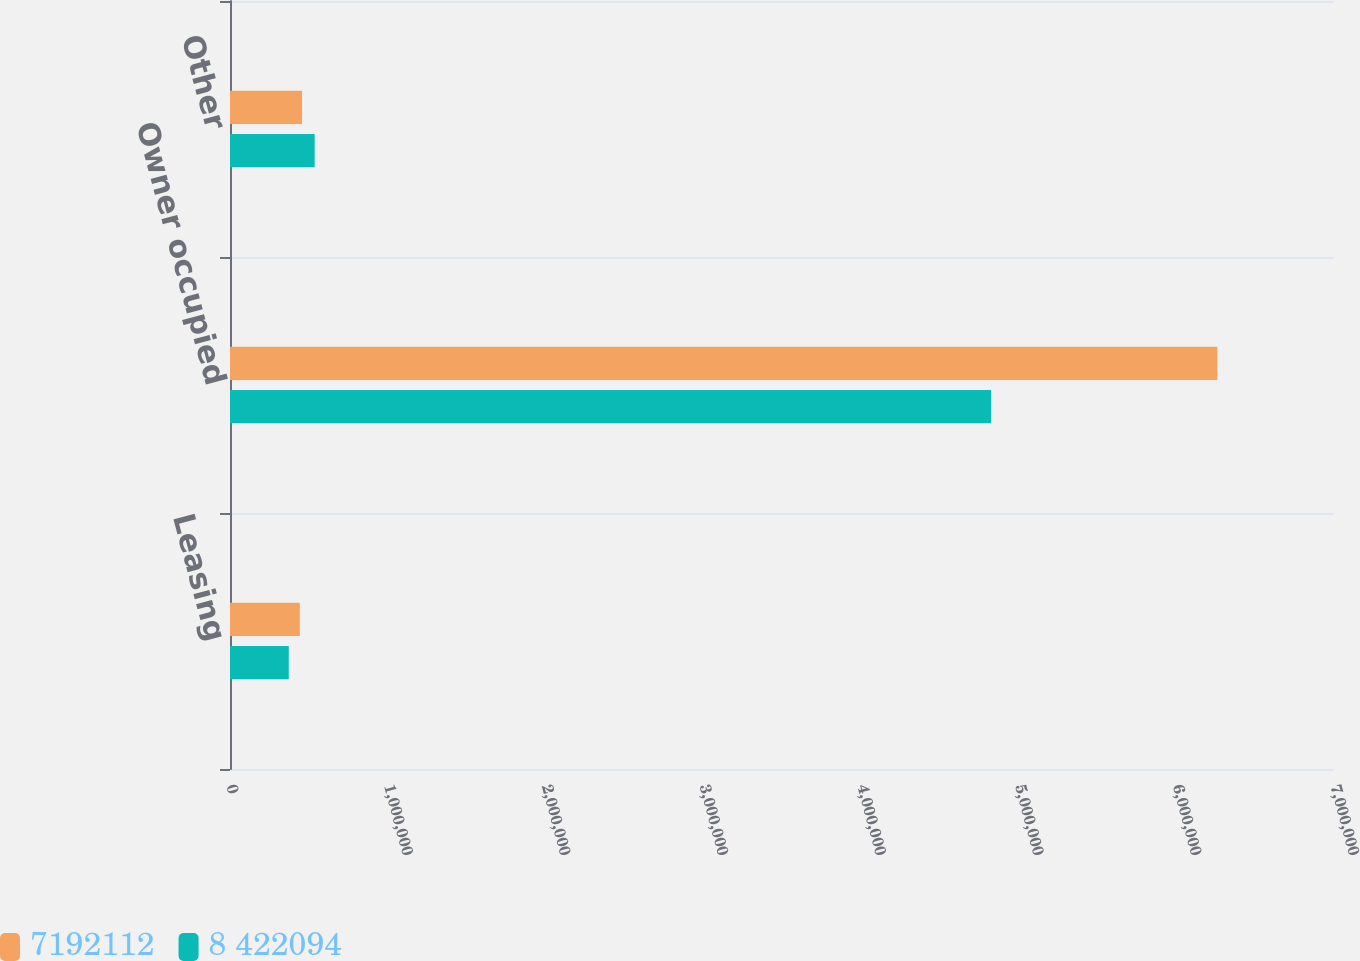Convert chart. <chart><loc_0><loc_0><loc_500><loc_500><stacked_bar_chart><ecel><fcel>Leasing<fcel>Owner occupied<fcel>Other<nl><fcel>7192112<fcel>442440<fcel>6.26022e+06<fcel>456942<nl><fcel>8 422094<fcel>372647<fcel>4.82538e+06<fcel>536927<nl></chart> 